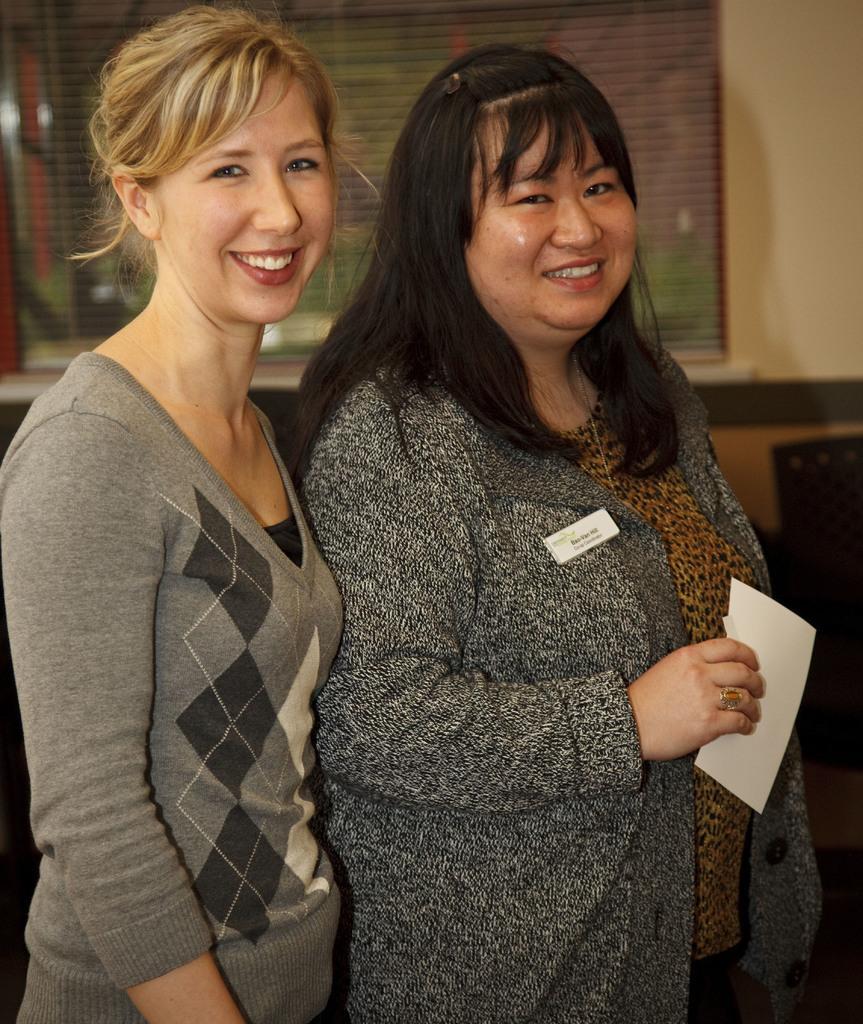In one or two sentences, can you explain what this image depicts? In the image two women are standing and smiling. Behind them there is a wall, on the wall there is a window. 